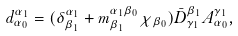<formula> <loc_0><loc_0><loc_500><loc_500>d _ { \alpha _ { 0 } } ^ { \alpha _ { 1 } } = ( \delta _ { \beta _ { 1 } } ^ { \alpha _ { 1 } } + m _ { \beta _ { 1 } } ^ { \alpha _ { 1 } \beta _ { 0 } } \chi _ { \beta _ { 0 } } ) \bar { D } _ { \gamma _ { 1 } } ^ { \beta _ { 1 } } A _ { \alpha _ { 0 } } ^ { \gamma _ { 1 } } ,</formula> 